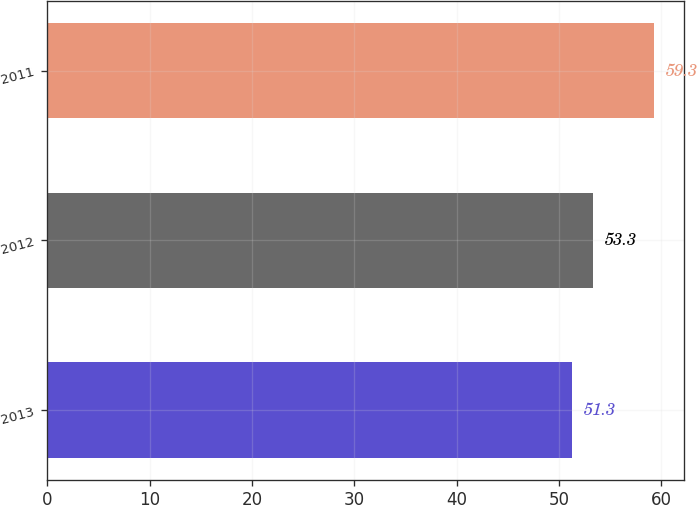Convert chart. <chart><loc_0><loc_0><loc_500><loc_500><bar_chart><fcel>2013<fcel>2012<fcel>2011<nl><fcel>51.3<fcel>53.3<fcel>59.3<nl></chart> 